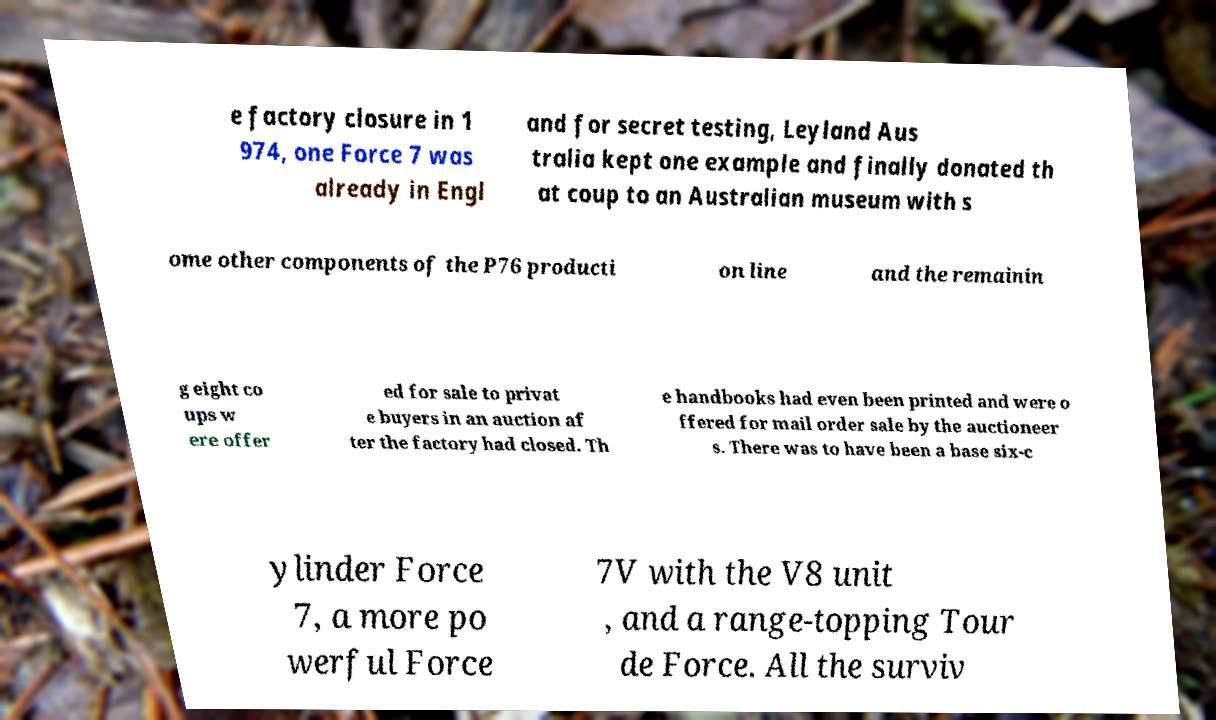Can you read and provide the text displayed in the image?This photo seems to have some interesting text. Can you extract and type it out for me? e factory closure in 1 974, one Force 7 was already in Engl and for secret testing, Leyland Aus tralia kept one example and finally donated th at coup to an Australian museum with s ome other components of the P76 producti on line and the remainin g eight co ups w ere offer ed for sale to privat e buyers in an auction af ter the factory had closed. Th e handbooks had even been printed and were o ffered for mail order sale by the auctioneer s. There was to have been a base six-c ylinder Force 7, a more po werful Force 7V with the V8 unit , and a range-topping Tour de Force. All the surviv 